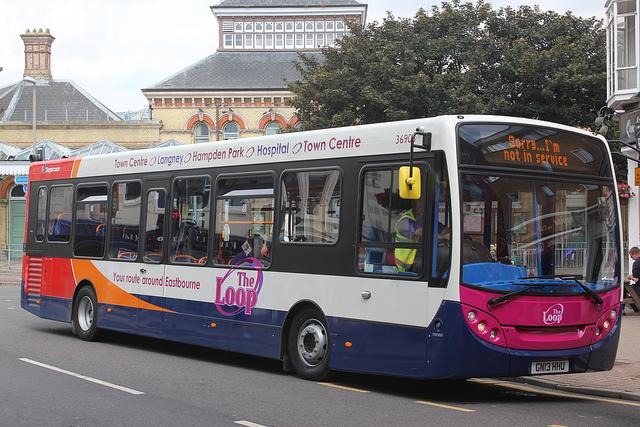Are the windshield wipers on?
Answer briefly. No. What is the color of the side mirror?
Keep it brief. Yellow. Is the bus empty?
Be succinct. Yes. What does the writing on the bus say to be proud of?
Give a very brief answer. Loop. What word is seen written on the white background of the bus?
Answer briefly. Loop. 